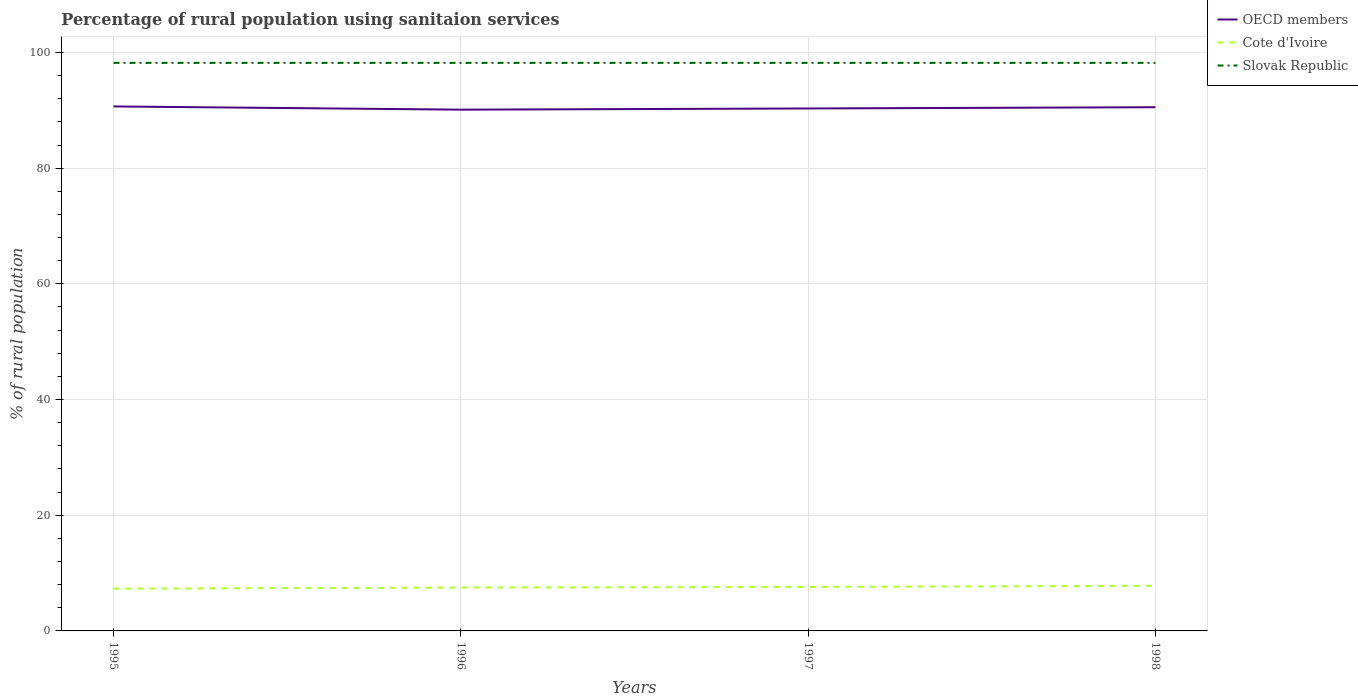Does the line corresponding to OECD members intersect with the line corresponding to Cote d'Ivoire?
Your answer should be very brief. No. Across all years, what is the maximum percentage of rural population using sanitaion services in Slovak Republic?
Give a very brief answer. 98.2. What is the difference between the highest and the second highest percentage of rural population using sanitaion services in OECD members?
Provide a short and direct response. 0.56. What is the difference between the highest and the lowest percentage of rural population using sanitaion services in Slovak Republic?
Keep it short and to the point. 0. Is the percentage of rural population using sanitaion services in Cote d'Ivoire strictly greater than the percentage of rural population using sanitaion services in OECD members over the years?
Your answer should be compact. Yes. Does the graph contain any zero values?
Your answer should be compact. No. How many legend labels are there?
Make the answer very short. 3. What is the title of the graph?
Offer a very short reply. Percentage of rural population using sanitaion services. What is the label or title of the X-axis?
Provide a short and direct response. Years. What is the label or title of the Y-axis?
Keep it short and to the point. % of rural population. What is the % of rural population in OECD members in 1995?
Make the answer very short. 90.67. What is the % of rural population of Slovak Republic in 1995?
Your answer should be compact. 98.2. What is the % of rural population of OECD members in 1996?
Provide a succinct answer. 90.11. What is the % of rural population of Cote d'Ivoire in 1996?
Offer a very short reply. 7.5. What is the % of rural population in Slovak Republic in 1996?
Ensure brevity in your answer.  98.2. What is the % of rural population in OECD members in 1997?
Keep it short and to the point. 90.32. What is the % of rural population in Slovak Republic in 1997?
Your answer should be very brief. 98.2. What is the % of rural population of OECD members in 1998?
Keep it short and to the point. 90.53. What is the % of rural population of Cote d'Ivoire in 1998?
Offer a very short reply. 7.8. What is the % of rural population of Slovak Republic in 1998?
Ensure brevity in your answer.  98.2. Across all years, what is the maximum % of rural population of OECD members?
Your answer should be compact. 90.67. Across all years, what is the maximum % of rural population in Slovak Republic?
Your answer should be very brief. 98.2. Across all years, what is the minimum % of rural population in OECD members?
Your answer should be very brief. 90.11. Across all years, what is the minimum % of rural population in Slovak Republic?
Offer a very short reply. 98.2. What is the total % of rural population in OECD members in the graph?
Your answer should be very brief. 361.63. What is the total % of rural population in Cote d'Ivoire in the graph?
Your answer should be very brief. 30.2. What is the total % of rural population of Slovak Republic in the graph?
Offer a very short reply. 392.8. What is the difference between the % of rural population of OECD members in 1995 and that in 1996?
Your answer should be very brief. 0.56. What is the difference between the % of rural population of OECD members in 1995 and that in 1997?
Give a very brief answer. 0.35. What is the difference between the % of rural population in Cote d'Ivoire in 1995 and that in 1997?
Your response must be concise. -0.3. What is the difference between the % of rural population in Slovak Republic in 1995 and that in 1997?
Provide a short and direct response. 0. What is the difference between the % of rural population in OECD members in 1995 and that in 1998?
Make the answer very short. 0.13. What is the difference between the % of rural population in OECD members in 1996 and that in 1997?
Your response must be concise. -0.21. What is the difference between the % of rural population of Cote d'Ivoire in 1996 and that in 1997?
Offer a terse response. -0.1. What is the difference between the % of rural population of OECD members in 1996 and that in 1998?
Your answer should be compact. -0.42. What is the difference between the % of rural population of Cote d'Ivoire in 1996 and that in 1998?
Your answer should be compact. -0.3. What is the difference between the % of rural population in OECD members in 1997 and that in 1998?
Your response must be concise. -0.22. What is the difference between the % of rural population of Slovak Republic in 1997 and that in 1998?
Ensure brevity in your answer.  0. What is the difference between the % of rural population of OECD members in 1995 and the % of rural population of Cote d'Ivoire in 1996?
Provide a short and direct response. 83.17. What is the difference between the % of rural population in OECD members in 1995 and the % of rural population in Slovak Republic in 1996?
Your answer should be compact. -7.53. What is the difference between the % of rural population of Cote d'Ivoire in 1995 and the % of rural population of Slovak Republic in 1996?
Ensure brevity in your answer.  -90.9. What is the difference between the % of rural population in OECD members in 1995 and the % of rural population in Cote d'Ivoire in 1997?
Give a very brief answer. 83.07. What is the difference between the % of rural population in OECD members in 1995 and the % of rural population in Slovak Republic in 1997?
Offer a terse response. -7.53. What is the difference between the % of rural population in Cote d'Ivoire in 1995 and the % of rural population in Slovak Republic in 1997?
Your answer should be very brief. -90.9. What is the difference between the % of rural population in OECD members in 1995 and the % of rural population in Cote d'Ivoire in 1998?
Offer a very short reply. 82.87. What is the difference between the % of rural population in OECD members in 1995 and the % of rural population in Slovak Republic in 1998?
Provide a short and direct response. -7.53. What is the difference between the % of rural population in Cote d'Ivoire in 1995 and the % of rural population in Slovak Republic in 1998?
Give a very brief answer. -90.9. What is the difference between the % of rural population in OECD members in 1996 and the % of rural population in Cote d'Ivoire in 1997?
Give a very brief answer. 82.51. What is the difference between the % of rural population in OECD members in 1996 and the % of rural population in Slovak Republic in 1997?
Give a very brief answer. -8.09. What is the difference between the % of rural population in Cote d'Ivoire in 1996 and the % of rural population in Slovak Republic in 1997?
Give a very brief answer. -90.7. What is the difference between the % of rural population in OECD members in 1996 and the % of rural population in Cote d'Ivoire in 1998?
Provide a succinct answer. 82.31. What is the difference between the % of rural population in OECD members in 1996 and the % of rural population in Slovak Republic in 1998?
Provide a succinct answer. -8.09. What is the difference between the % of rural population in Cote d'Ivoire in 1996 and the % of rural population in Slovak Republic in 1998?
Provide a succinct answer. -90.7. What is the difference between the % of rural population in OECD members in 1997 and the % of rural population in Cote d'Ivoire in 1998?
Keep it short and to the point. 82.52. What is the difference between the % of rural population of OECD members in 1997 and the % of rural population of Slovak Republic in 1998?
Provide a short and direct response. -7.88. What is the difference between the % of rural population of Cote d'Ivoire in 1997 and the % of rural population of Slovak Republic in 1998?
Provide a succinct answer. -90.6. What is the average % of rural population of OECD members per year?
Ensure brevity in your answer.  90.41. What is the average % of rural population in Cote d'Ivoire per year?
Your response must be concise. 7.55. What is the average % of rural population in Slovak Republic per year?
Provide a succinct answer. 98.2. In the year 1995, what is the difference between the % of rural population in OECD members and % of rural population in Cote d'Ivoire?
Ensure brevity in your answer.  83.37. In the year 1995, what is the difference between the % of rural population in OECD members and % of rural population in Slovak Republic?
Offer a terse response. -7.53. In the year 1995, what is the difference between the % of rural population of Cote d'Ivoire and % of rural population of Slovak Republic?
Your response must be concise. -90.9. In the year 1996, what is the difference between the % of rural population of OECD members and % of rural population of Cote d'Ivoire?
Offer a very short reply. 82.61. In the year 1996, what is the difference between the % of rural population of OECD members and % of rural population of Slovak Republic?
Provide a short and direct response. -8.09. In the year 1996, what is the difference between the % of rural population of Cote d'Ivoire and % of rural population of Slovak Republic?
Ensure brevity in your answer.  -90.7. In the year 1997, what is the difference between the % of rural population of OECD members and % of rural population of Cote d'Ivoire?
Your answer should be very brief. 82.72. In the year 1997, what is the difference between the % of rural population in OECD members and % of rural population in Slovak Republic?
Offer a terse response. -7.88. In the year 1997, what is the difference between the % of rural population in Cote d'Ivoire and % of rural population in Slovak Republic?
Offer a very short reply. -90.6. In the year 1998, what is the difference between the % of rural population in OECD members and % of rural population in Cote d'Ivoire?
Provide a succinct answer. 82.73. In the year 1998, what is the difference between the % of rural population in OECD members and % of rural population in Slovak Republic?
Your answer should be compact. -7.67. In the year 1998, what is the difference between the % of rural population in Cote d'Ivoire and % of rural population in Slovak Republic?
Your answer should be compact. -90.4. What is the ratio of the % of rural population in OECD members in 1995 to that in 1996?
Your answer should be compact. 1.01. What is the ratio of the % of rural population in Cote d'Ivoire in 1995 to that in 1996?
Your response must be concise. 0.97. What is the ratio of the % of rural population in Cote d'Ivoire in 1995 to that in 1997?
Keep it short and to the point. 0.96. What is the ratio of the % of rural population of Cote d'Ivoire in 1995 to that in 1998?
Your answer should be compact. 0.94. What is the ratio of the % of rural population of Slovak Republic in 1995 to that in 1998?
Ensure brevity in your answer.  1. What is the ratio of the % of rural population in OECD members in 1996 to that in 1997?
Keep it short and to the point. 1. What is the ratio of the % of rural population in OECD members in 1996 to that in 1998?
Ensure brevity in your answer.  1. What is the ratio of the % of rural population of Cote d'Ivoire in 1996 to that in 1998?
Give a very brief answer. 0.96. What is the ratio of the % of rural population of Slovak Republic in 1996 to that in 1998?
Give a very brief answer. 1. What is the ratio of the % of rural population of Cote d'Ivoire in 1997 to that in 1998?
Provide a short and direct response. 0.97. What is the ratio of the % of rural population in Slovak Republic in 1997 to that in 1998?
Keep it short and to the point. 1. What is the difference between the highest and the second highest % of rural population of OECD members?
Provide a succinct answer. 0.13. What is the difference between the highest and the second highest % of rural population in Cote d'Ivoire?
Keep it short and to the point. 0.2. What is the difference between the highest and the lowest % of rural population in OECD members?
Provide a short and direct response. 0.56. What is the difference between the highest and the lowest % of rural population in Slovak Republic?
Offer a very short reply. 0. 